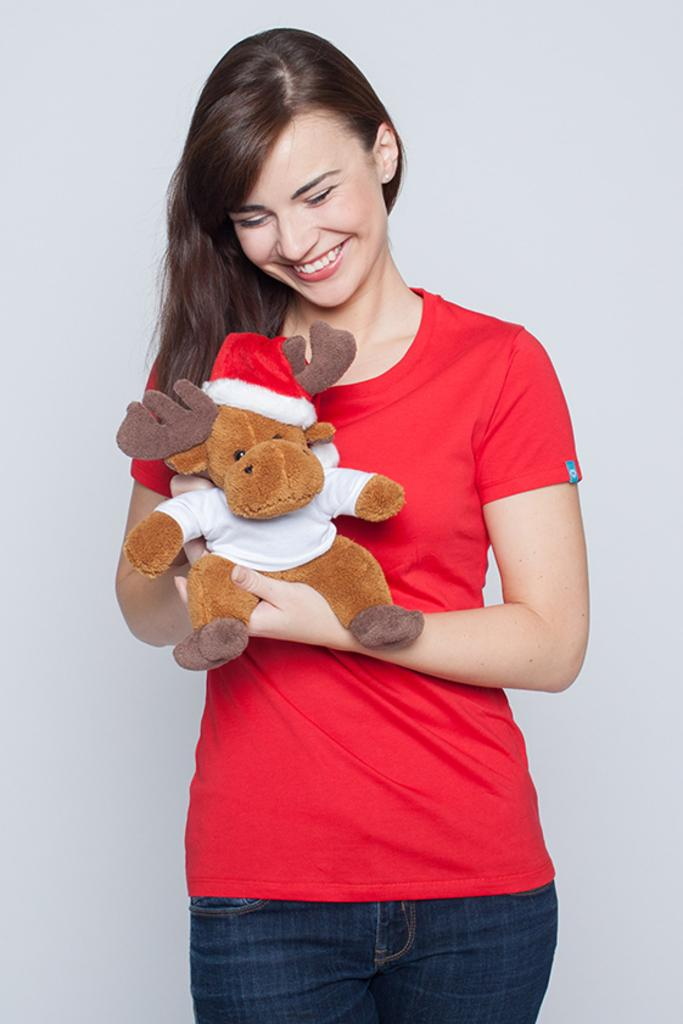What is the main subject of the image? The main subject of the image is a woman. What is the woman doing in the image? The woman is standing and smiling in the image. What is the woman wearing in the image? The woman is wearing a red t-shirt in the image. What is the woman holding in the image? The woman is holding a soft toy in the image. What can be seen in the background of the image? There is a wall at the back of the image. What color is the hot salt in the image? There is no hot salt present in the image. The image features a woman standing, smiling, wearing a red t-shirt, and holding a soft toy, with a wall in the background. 